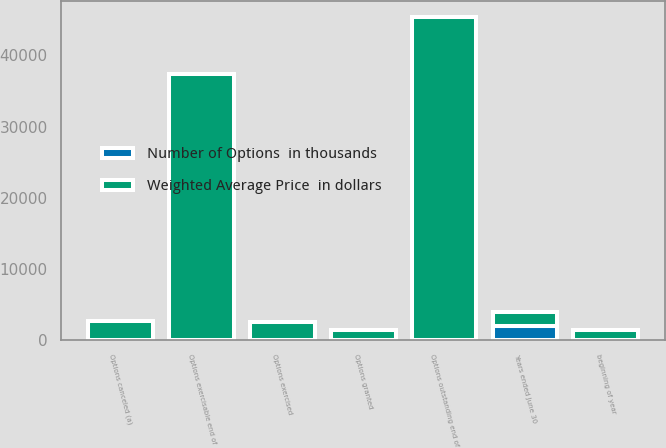Convert chart to OTSL. <chart><loc_0><loc_0><loc_500><loc_500><stacked_bar_chart><ecel><fcel>Years ended June 30<fcel>beginning of year<fcel>Options granted<fcel>Options exercised<fcel>Options canceled (a)<fcel>Options outstanding end of<fcel>Options exercisable end of<nl><fcel>Weighted Average Price  in dollars<fcel>2009<fcel>1390<fcel>1390<fcel>2502<fcel>2695<fcel>45320<fcel>37318<nl><fcel>Number of Options  in thousands<fcel>2009<fcel>41<fcel>39<fcel>36<fcel>41<fcel>41<fcel>41<nl></chart> 